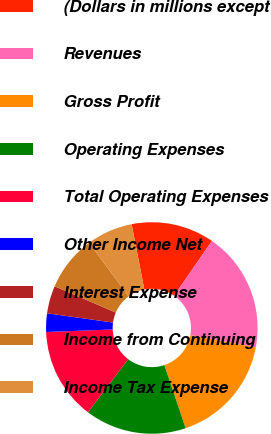Convert chart. <chart><loc_0><loc_0><loc_500><loc_500><pie_chart><fcel>(Dollars in millions except<fcel>Revenues<fcel>Gross Profit<fcel>Operating Expenses<fcel>Total Operating Expenses<fcel>Other Income Net<fcel>Interest Expense<fcel>Income from Continuing<fcel>Income Tax Expense<nl><fcel>12.68%<fcel>18.31%<fcel>16.9%<fcel>15.49%<fcel>14.08%<fcel>2.82%<fcel>4.23%<fcel>8.45%<fcel>7.04%<nl></chart> 